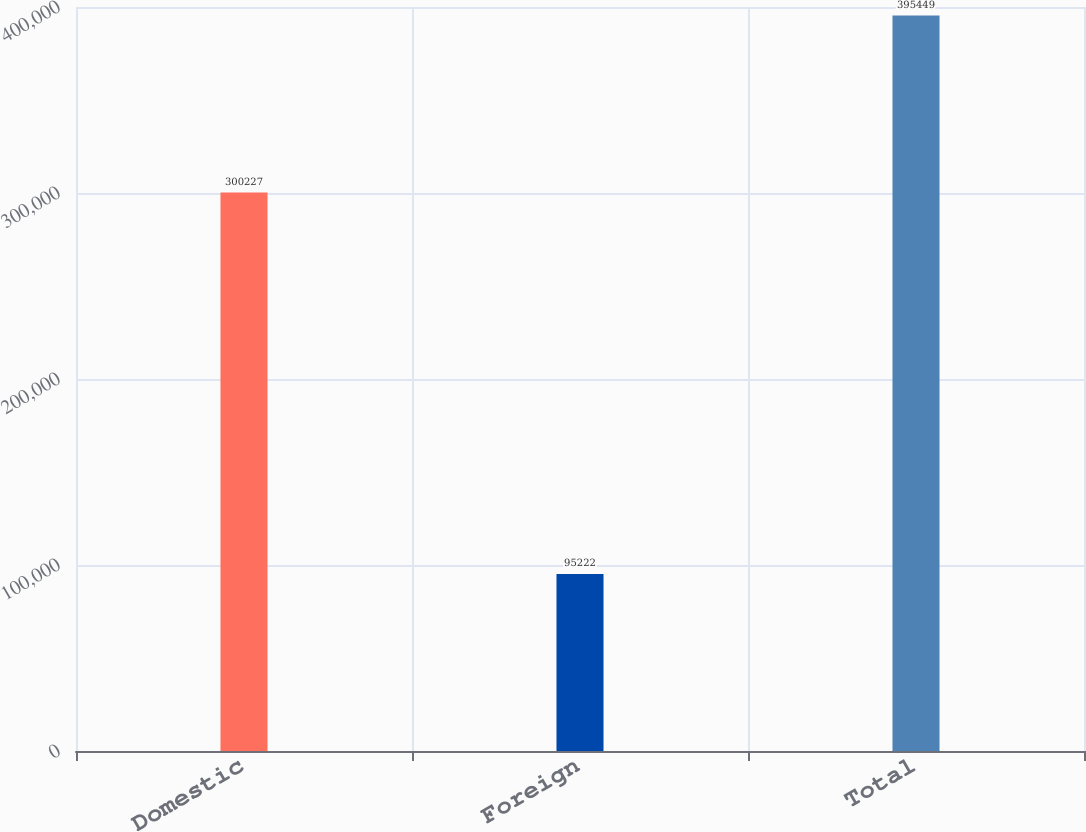Convert chart to OTSL. <chart><loc_0><loc_0><loc_500><loc_500><bar_chart><fcel>Domestic<fcel>Foreign<fcel>Total<nl><fcel>300227<fcel>95222<fcel>395449<nl></chart> 